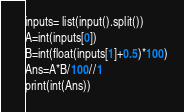<code> <loc_0><loc_0><loc_500><loc_500><_Python_>inputs= list(input().split())
A=int(inputs[0])
B=int(float(inputs[1]+0.5)*100)
Ans=A*B/100//1
print(int(Ans))
</code> 